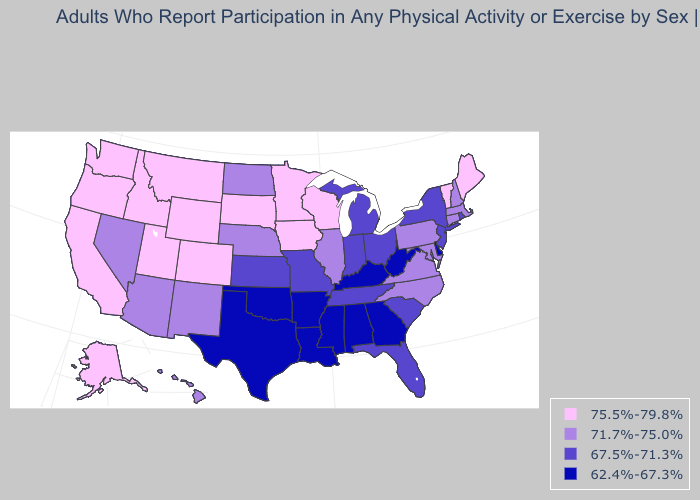Name the states that have a value in the range 62.4%-67.3%?
Write a very short answer. Alabama, Arkansas, Delaware, Georgia, Kentucky, Louisiana, Mississippi, Oklahoma, Texas, West Virginia. Which states have the highest value in the USA?
Keep it brief. Alaska, California, Colorado, Idaho, Iowa, Maine, Minnesota, Montana, Oregon, South Dakota, Utah, Vermont, Washington, Wisconsin, Wyoming. What is the value of Nebraska?
Give a very brief answer. 71.7%-75.0%. What is the highest value in the MidWest ?
Write a very short answer. 75.5%-79.8%. Does Texas have the same value as Louisiana?
Be succinct. Yes. Name the states that have a value in the range 71.7%-75.0%?
Give a very brief answer. Arizona, Connecticut, Hawaii, Illinois, Maryland, Massachusetts, Nebraska, Nevada, New Hampshire, New Mexico, North Carolina, North Dakota, Pennsylvania, Virginia. Does New Mexico have the highest value in the West?
Give a very brief answer. No. Name the states that have a value in the range 67.5%-71.3%?
Quick response, please. Florida, Indiana, Kansas, Michigan, Missouri, New Jersey, New York, Ohio, Rhode Island, South Carolina, Tennessee. What is the lowest value in the USA?
Give a very brief answer. 62.4%-67.3%. What is the lowest value in the USA?
Be succinct. 62.4%-67.3%. What is the value of Wyoming?
Answer briefly. 75.5%-79.8%. What is the highest value in the West ?
Quick response, please. 75.5%-79.8%. Name the states that have a value in the range 67.5%-71.3%?
Write a very short answer. Florida, Indiana, Kansas, Michigan, Missouri, New Jersey, New York, Ohio, Rhode Island, South Carolina, Tennessee. Does Idaho have the same value as Alaska?
Give a very brief answer. Yes. Name the states that have a value in the range 62.4%-67.3%?
Concise answer only. Alabama, Arkansas, Delaware, Georgia, Kentucky, Louisiana, Mississippi, Oklahoma, Texas, West Virginia. 